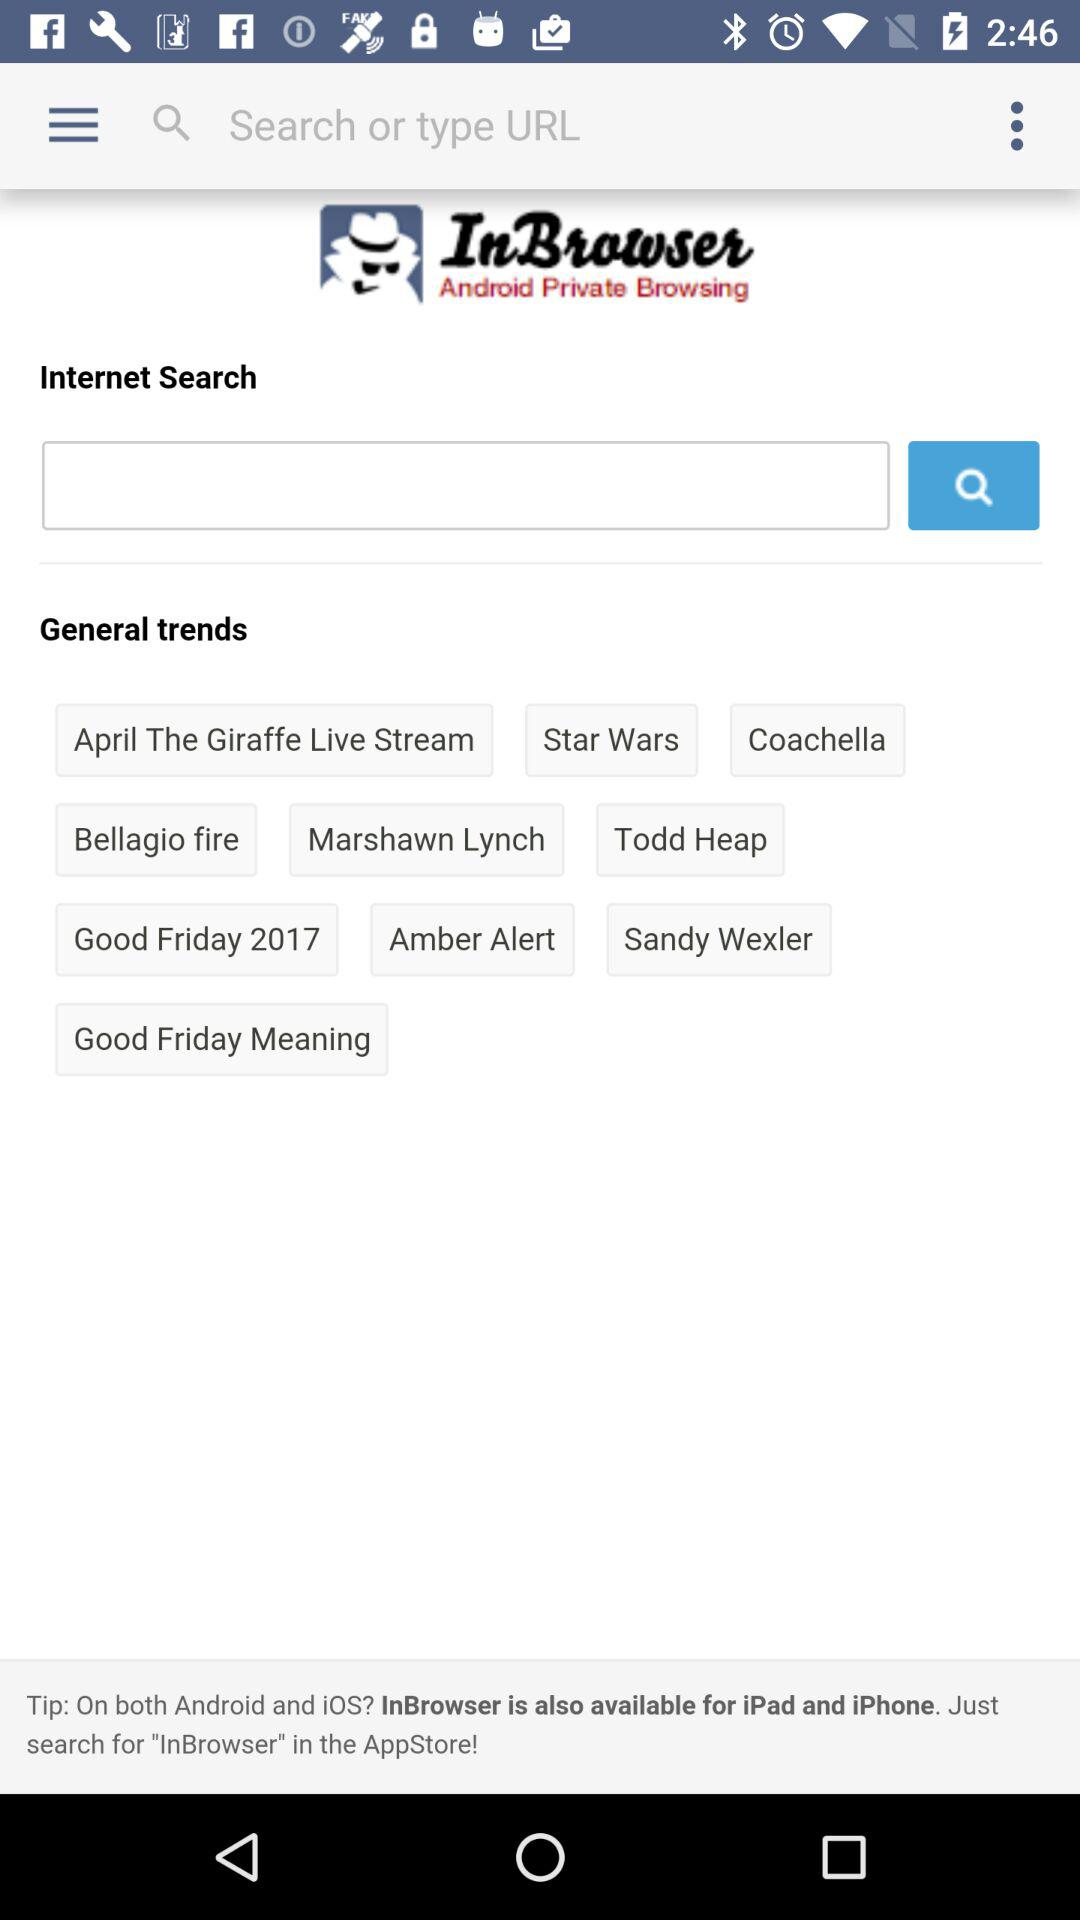What is the browser name? The browser name is "InBrowser". 